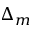Convert formula to latex. <formula><loc_0><loc_0><loc_500><loc_500>\Delta _ { m }</formula> 